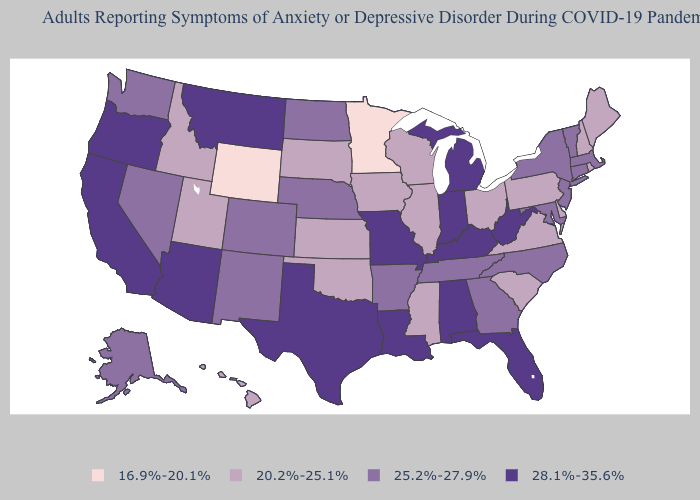Which states hav the highest value in the Northeast?
Give a very brief answer. Connecticut, Massachusetts, New Jersey, New York, Vermont. What is the highest value in the USA?
Keep it brief. 28.1%-35.6%. Does the map have missing data?
Answer briefly. No. What is the value of Wisconsin?
Concise answer only. 20.2%-25.1%. What is the value of New Jersey?
Be succinct. 25.2%-27.9%. Which states have the lowest value in the USA?
Short answer required. Minnesota, Wyoming. Which states have the highest value in the USA?
Concise answer only. Alabama, Arizona, California, Florida, Indiana, Kentucky, Louisiana, Michigan, Missouri, Montana, Oregon, Texas, West Virginia. Does Michigan have a lower value than South Dakota?
Keep it brief. No. What is the value of New Hampshire?
Write a very short answer. 20.2%-25.1%. What is the lowest value in the USA?
Answer briefly. 16.9%-20.1%. Does the first symbol in the legend represent the smallest category?
Write a very short answer. Yes. Name the states that have a value in the range 28.1%-35.6%?
Answer briefly. Alabama, Arizona, California, Florida, Indiana, Kentucky, Louisiana, Michigan, Missouri, Montana, Oregon, Texas, West Virginia. What is the value of New Hampshire?
Answer briefly. 20.2%-25.1%. Among the states that border Arkansas , does Tennessee have the lowest value?
Answer briefly. No. Name the states that have a value in the range 20.2%-25.1%?
Short answer required. Delaware, Hawaii, Idaho, Illinois, Iowa, Kansas, Maine, Mississippi, New Hampshire, Ohio, Oklahoma, Pennsylvania, Rhode Island, South Carolina, South Dakota, Utah, Virginia, Wisconsin. 